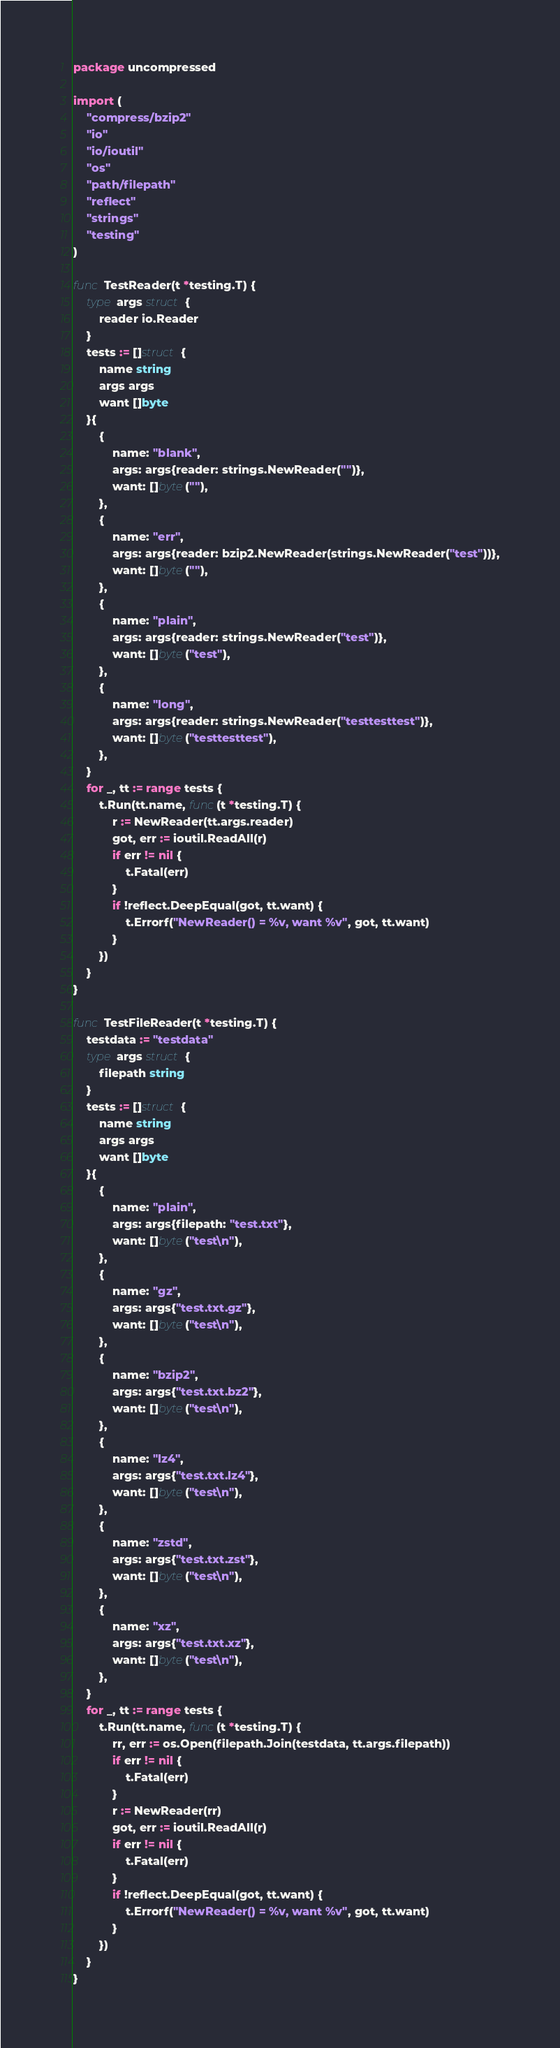Convert code to text. <code><loc_0><loc_0><loc_500><loc_500><_Go_>package uncompressed

import (
	"compress/bzip2"
	"io"
	"io/ioutil"
	"os"
	"path/filepath"
	"reflect"
	"strings"
	"testing"
)

func TestReader(t *testing.T) {
	type args struct {
		reader io.Reader
	}
	tests := []struct {
		name string
		args args
		want []byte
	}{
		{
			name: "blank",
			args: args{reader: strings.NewReader("")},
			want: []byte(""),
		},
		{
			name: "err",
			args: args{reader: bzip2.NewReader(strings.NewReader("test"))},
			want: []byte(""),
		},
		{
			name: "plain",
			args: args{reader: strings.NewReader("test")},
			want: []byte("test"),
		},
		{
			name: "long",
			args: args{reader: strings.NewReader("testtesttest")},
			want: []byte("testtesttest"),
		},
	}
	for _, tt := range tests {
		t.Run(tt.name, func(t *testing.T) {
			r := NewReader(tt.args.reader)
			got, err := ioutil.ReadAll(r)
			if err != nil {
				t.Fatal(err)
			}
			if !reflect.DeepEqual(got, tt.want) {
				t.Errorf("NewReader() = %v, want %v", got, tt.want)
			}
		})
	}
}

func TestFileReader(t *testing.T) {
	testdata := "testdata"
	type args struct {
		filepath string
	}
	tests := []struct {
		name string
		args args
		want []byte
	}{
		{
			name: "plain",
			args: args{filepath: "test.txt"},
			want: []byte("test\n"),
		},
		{
			name: "gz",
			args: args{"test.txt.gz"},
			want: []byte("test\n"),
		},
		{
			name: "bzip2",
			args: args{"test.txt.bz2"},
			want: []byte("test\n"),
		},
		{
			name: "lz4",
			args: args{"test.txt.lz4"},
			want: []byte("test\n"),
		},
		{
			name: "zstd",
			args: args{"test.txt.zst"},
			want: []byte("test\n"),
		},
		{
			name: "xz",
			args: args{"test.txt.xz"},
			want: []byte("test\n"),
		},
	}
	for _, tt := range tests {
		t.Run(tt.name, func(t *testing.T) {
			rr, err := os.Open(filepath.Join(testdata, tt.args.filepath))
			if err != nil {
				t.Fatal(err)
			}
			r := NewReader(rr)
			got, err := ioutil.ReadAll(r)
			if err != nil {
				t.Fatal(err)
			}
			if !reflect.DeepEqual(got, tt.want) {
				t.Errorf("NewReader() = %v, want %v", got, tt.want)
			}
		})
	}
}
</code> 